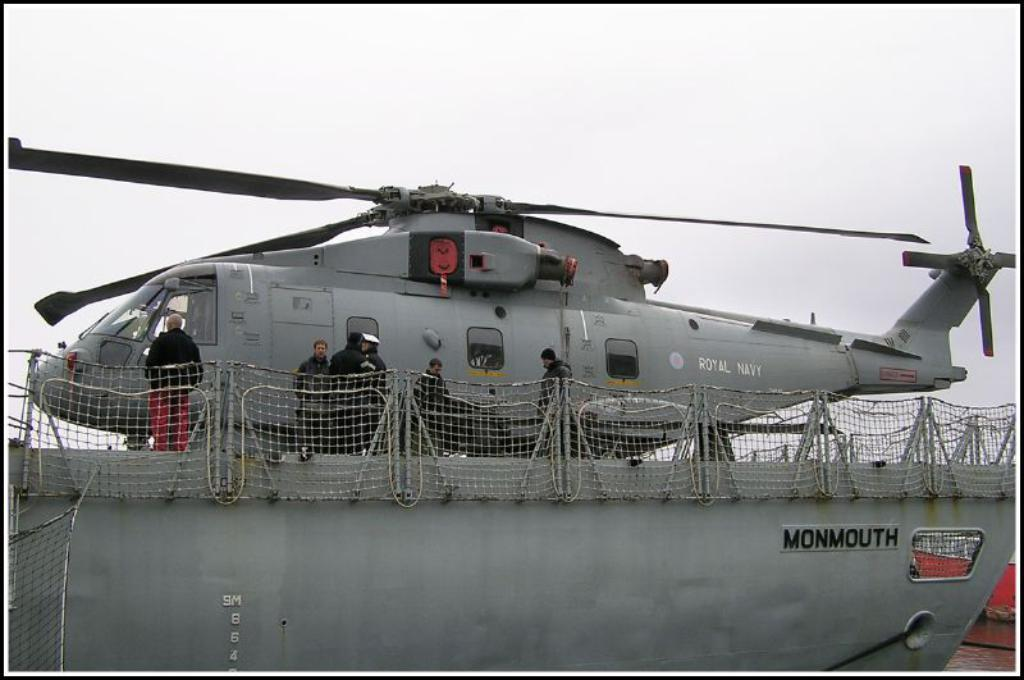<image>
Relay a brief, clear account of the picture shown. A Royal Navy helicopter is shown on board the Monmouth. 